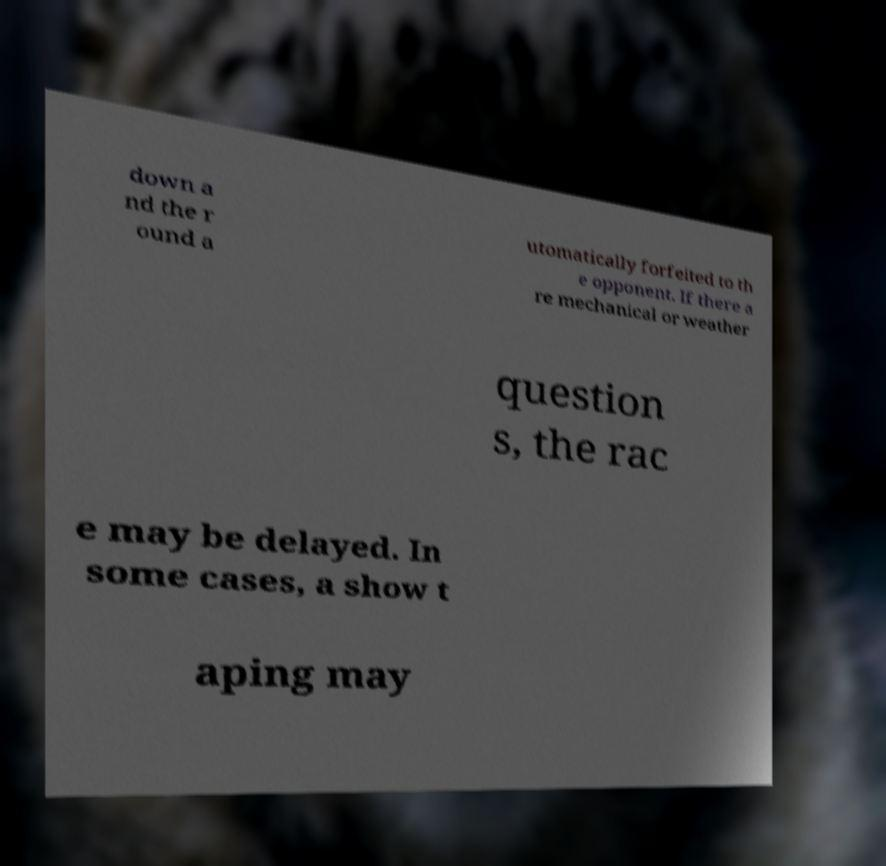Can you read and provide the text displayed in the image?This photo seems to have some interesting text. Can you extract and type it out for me? down a nd the r ound a utomatically forfeited to th e opponent. If there a re mechanical or weather question s, the rac e may be delayed. In some cases, a show t aping may 